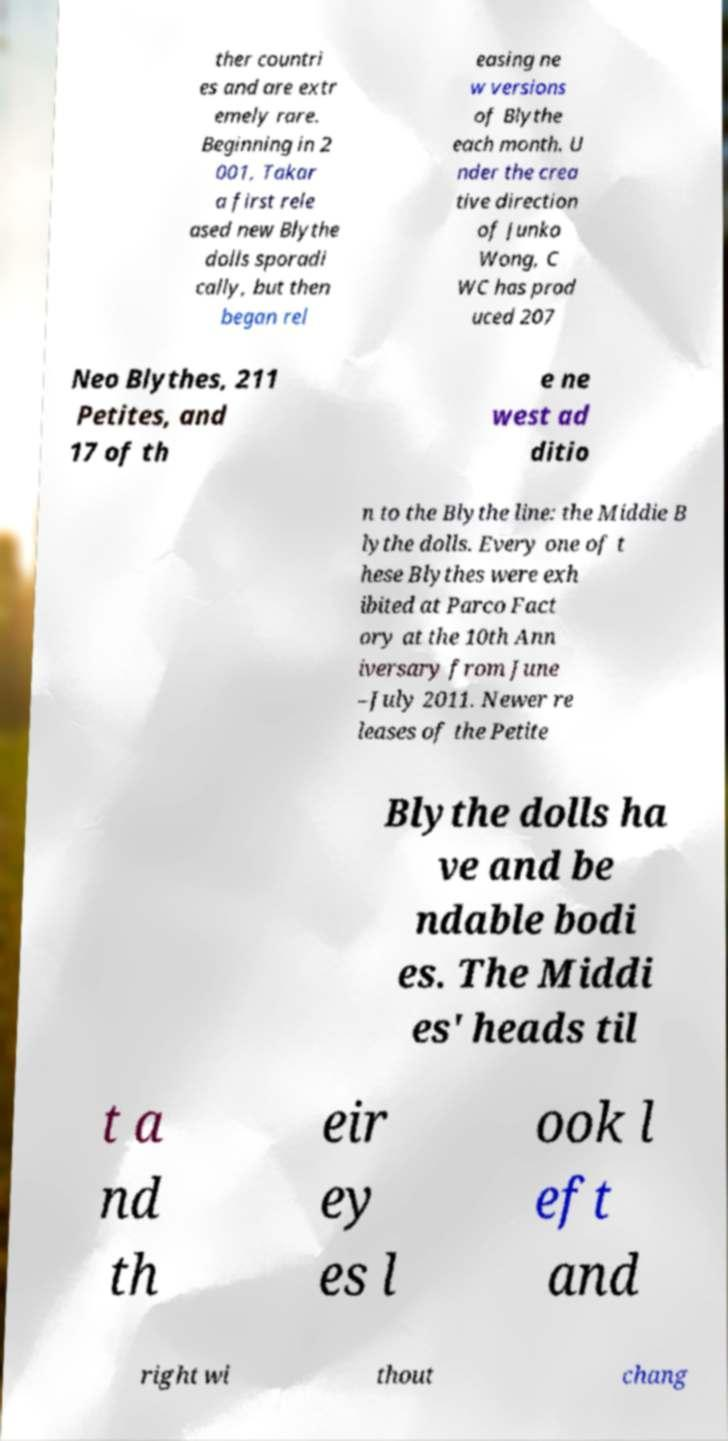I need the written content from this picture converted into text. Can you do that? ther countri es and are extr emely rare. Beginning in 2 001, Takar a first rele ased new Blythe dolls sporadi cally, but then began rel easing ne w versions of Blythe each month. U nder the crea tive direction of Junko Wong, C WC has prod uced 207 Neo Blythes, 211 Petites, and 17 of th e ne west ad ditio n to the Blythe line: the Middie B lythe dolls. Every one of t hese Blythes were exh ibited at Parco Fact ory at the 10th Ann iversary from June –July 2011. Newer re leases of the Petite Blythe dolls ha ve and be ndable bodi es. The Middi es' heads til t a nd th eir ey es l ook l eft and right wi thout chang 